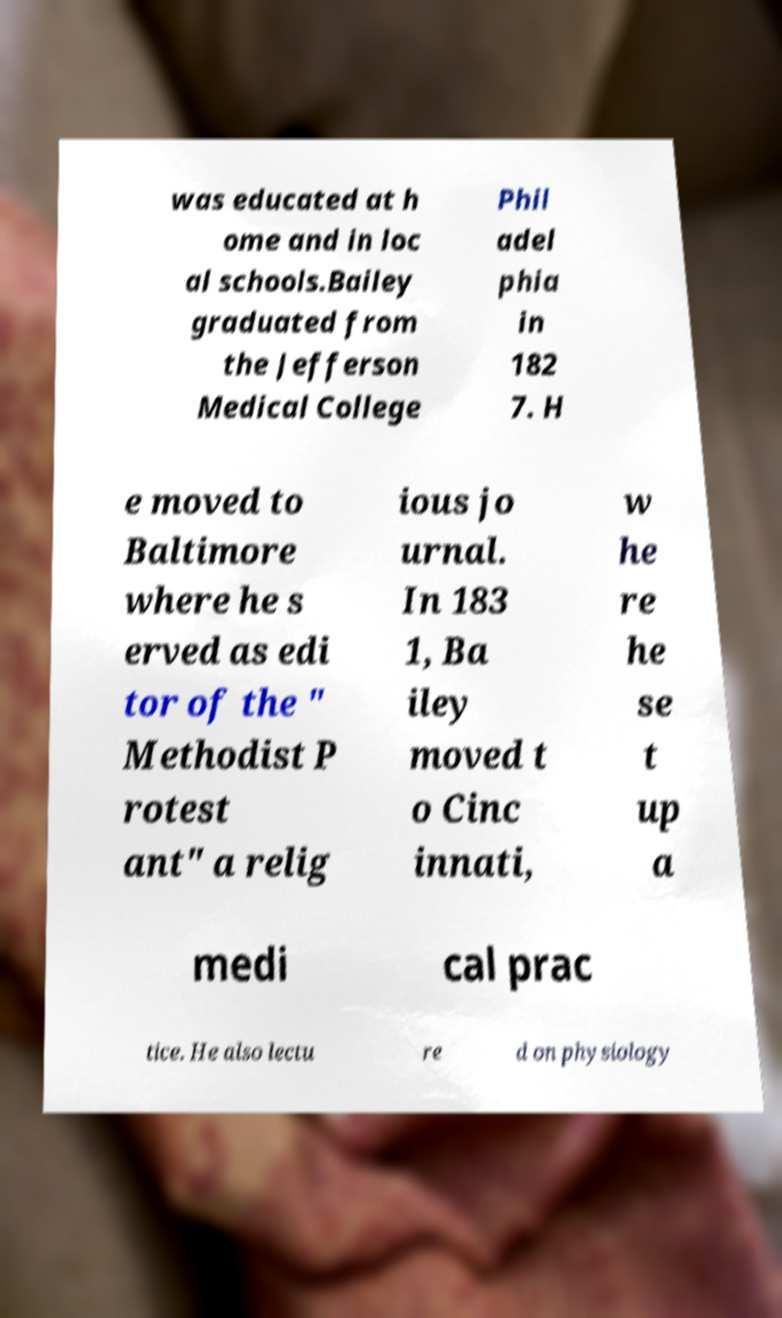Can you read and provide the text displayed in the image?This photo seems to have some interesting text. Can you extract and type it out for me? was educated at h ome and in loc al schools.Bailey graduated from the Jefferson Medical College Phil adel phia in 182 7. H e moved to Baltimore where he s erved as edi tor of the " Methodist P rotest ant" a relig ious jo urnal. In 183 1, Ba iley moved t o Cinc innati, w he re he se t up a medi cal prac tice. He also lectu re d on physiology 